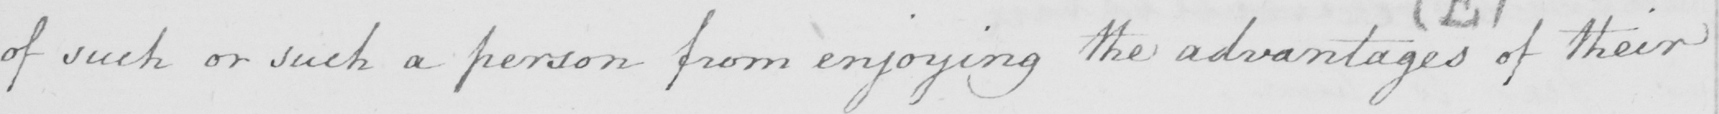Can you tell me what this handwritten text says? of such or such a person from enjoying the advantages of their 